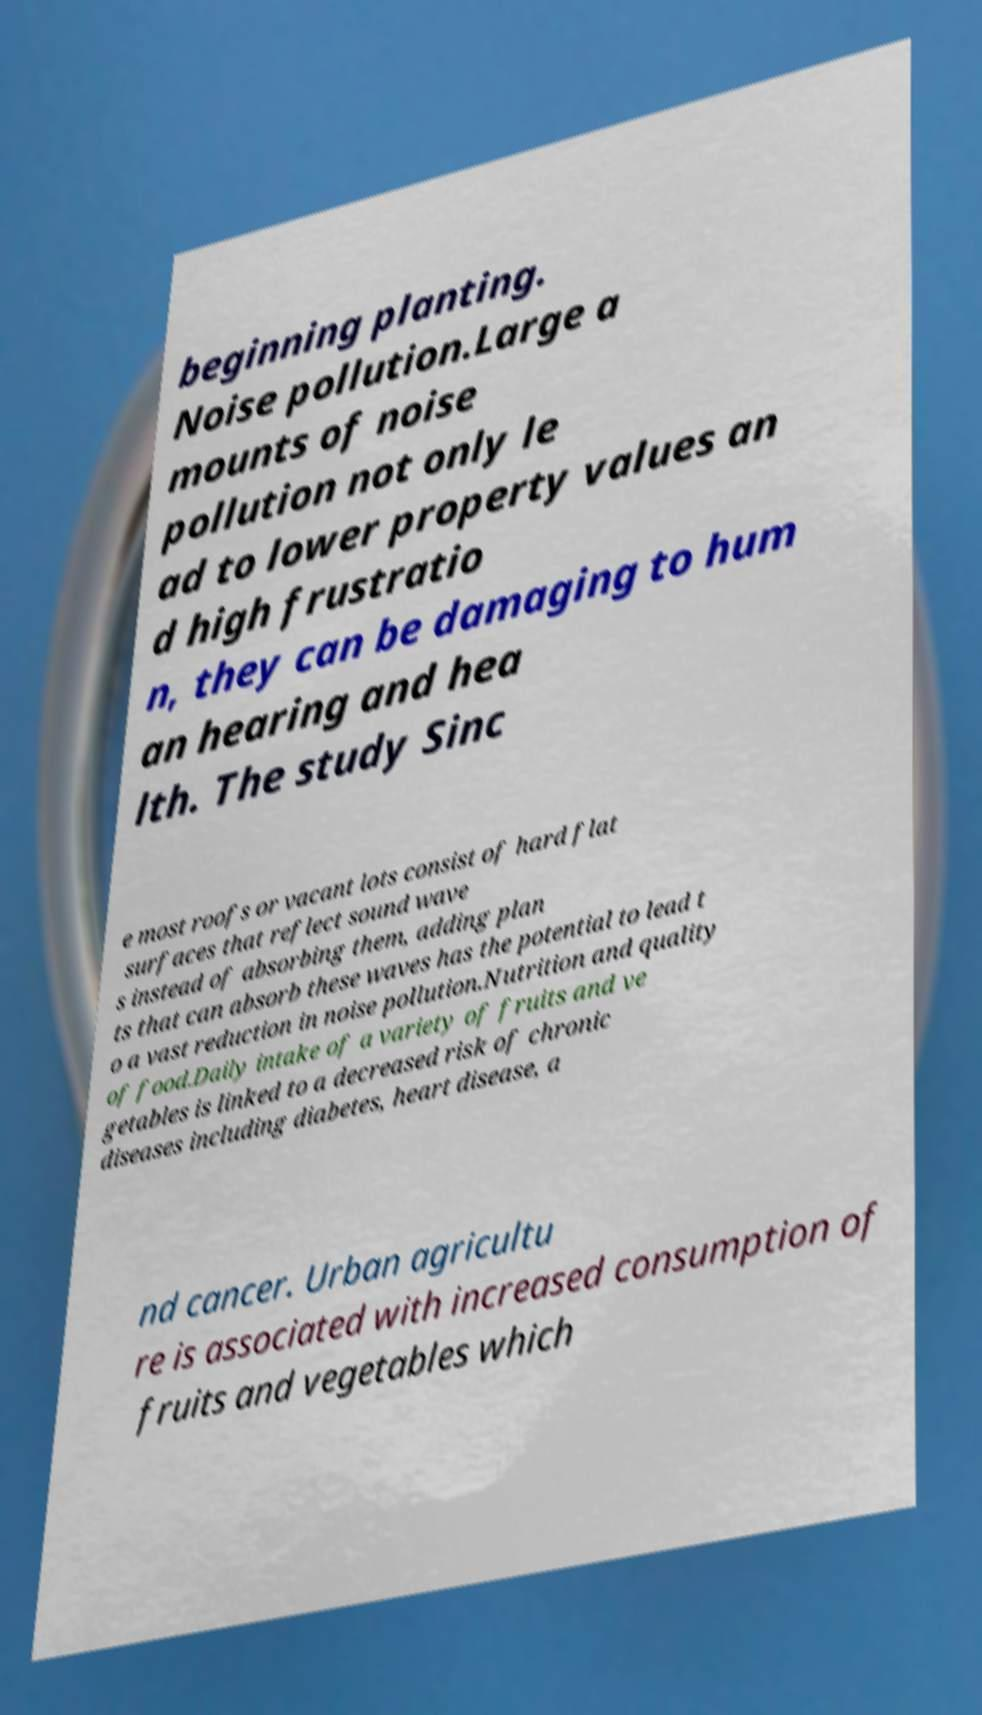Please identify and transcribe the text found in this image. beginning planting. Noise pollution.Large a mounts of noise pollution not only le ad to lower property values an d high frustratio n, they can be damaging to hum an hearing and hea lth. The study Sinc e most roofs or vacant lots consist of hard flat surfaces that reflect sound wave s instead of absorbing them, adding plan ts that can absorb these waves has the potential to lead t o a vast reduction in noise pollution.Nutrition and quality of food.Daily intake of a variety of fruits and ve getables is linked to a decreased risk of chronic diseases including diabetes, heart disease, a nd cancer. Urban agricultu re is associated with increased consumption of fruits and vegetables which 